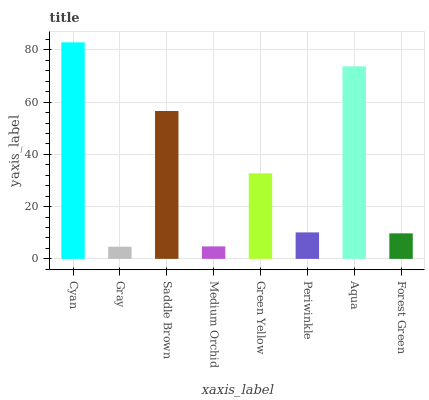Is Gray the minimum?
Answer yes or no. Yes. Is Cyan the maximum?
Answer yes or no. Yes. Is Saddle Brown the minimum?
Answer yes or no. No. Is Saddle Brown the maximum?
Answer yes or no. No. Is Saddle Brown greater than Gray?
Answer yes or no. Yes. Is Gray less than Saddle Brown?
Answer yes or no. Yes. Is Gray greater than Saddle Brown?
Answer yes or no. No. Is Saddle Brown less than Gray?
Answer yes or no. No. Is Green Yellow the high median?
Answer yes or no. Yes. Is Periwinkle the low median?
Answer yes or no. Yes. Is Medium Orchid the high median?
Answer yes or no. No. Is Medium Orchid the low median?
Answer yes or no. No. 